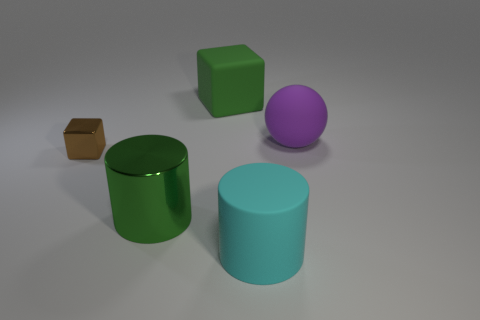What material is the cylinder that is to the right of the large thing that is behind the ball?
Your answer should be compact. Rubber. What size is the metallic cylinder?
Provide a succinct answer. Large. How many cyan things have the same size as the green matte thing?
Make the answer very short. 1. What number of green rubber objects are the same shape as the big cyan object?
Keep it short and to the point. 0. Are there an equal number of small objects on the right side of the purple rubber ball and big brown balls?
Provide a short and direct response. Yes. Is there any other thing that has the same size as the brown object?
Give a very brief answer. No. There is a cyan rubber object that is the same size as the purple rubber object; what is its shape?
Give a very brief answer. Cylinder. Is there another metallic thing of the same shape as the big cyan thing?
Keep it short and to the point. Yes. There is a big cylinder left of the cylinder that is in front of the big metallic thing; are there any green blocks in front of it?
Make the answer very short. No. Is the number of purple matte balls to the left of the small thing greater than the number of cyan cylinders behind the green rubber block?
Give a very brief answer. No. 